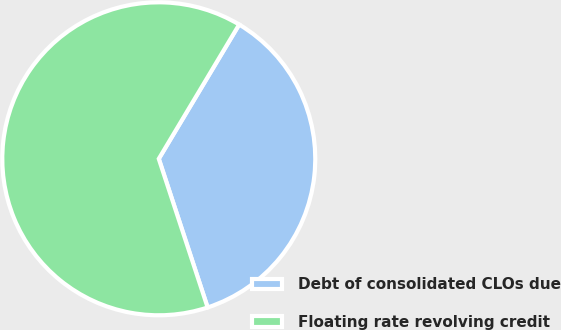Convert chart to OTSL. <chart><loc_0><loc_0><loc_500><loc_500><pie_chart><fcel>Debt of consolidated CLOs due<fcel>Floating rate revolving credit<nl><fcel>36.36%<fcel>63.64%<nl></chart> 